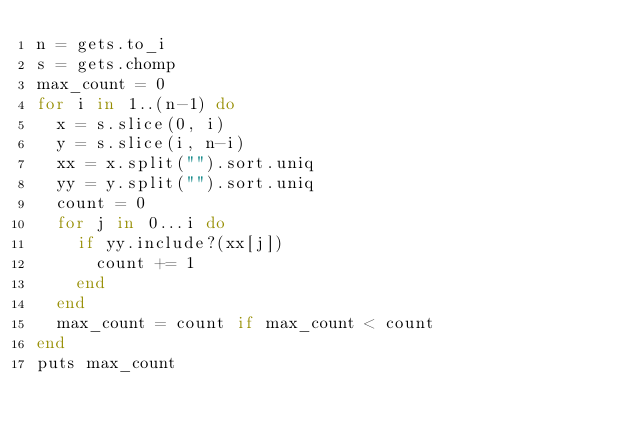<code> <loc_0><loc_0><loc_500><loc_500><_Ruby_>n = gets.to_i
s = gets.chomp
max_count = 0
for i in 1..(n-1) do
  x = s.slice(0, i)
  y = s.slice(i, n-i)
  xx = x.split("").sort.uniq
  yy = y.split("").sort.uniq
  count = 0
  for j in 0...i do
    if yy.include?(xx[j])
      count += 1
    end
  end
  max_count = count if max_count < count
end
puts max_count
</code> 